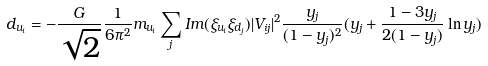<formula> <loc_0><loc_0><loc_500><loc_500>d _ { u _ { i } } = - \frac { G } { \sqrt { 2 } } \frac { 1 } { 6 \pi ^ { 2 } } m _ { u _ { i } } \sum _ { j } I m ( \xi _ { u _ { i } } \xi _ { d _ { j } } ) | V _ { i j } | ^ { 2 } \frac { y _ { j } } { ( 1 - y _ { j } ) ^ { 2 } } ( y _ { j } + \frac { 1 - 3 y _ { j } } { 2 ( 1 - y _ { j } ) } \ln y _ { j } )</formula> 